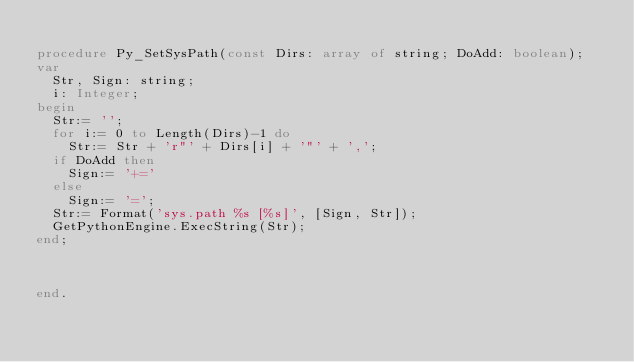Convert code to text. <code><loc_0><loc_0><loc_500><loc_500><_Pascal_>
procedure Py_SetSysPath(const Dirs: array of string; DoAdd: boolean);
var
  Str, Sign: string;
  i: Integer;
begin
  Str:= '';
  for i:= 0 to Length(Dirs)-1 do
    Str:= Str + 'r"' + Dirs[i] + '"' + ',';
  if DoAdd then
    Sign:= '+='
  else
    Sign:= '=';
  Str:= Format('sys.path %s [%s]', [Sign, Str]);
  GetPythonEngine.ExecString(Str);
end;



end.

</code> 